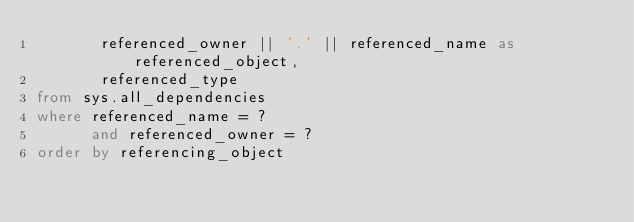Convert code to text. <code><loc_0><loc_0><loc_500><loc_500><_SQL_>       referenced_owner || '.' || referenced_name as referenced_object,
       referenced_type
from sys.all_dependencies
where referenced_name = ?
      and referenced_owner = ?
order by referencing_object</code> 